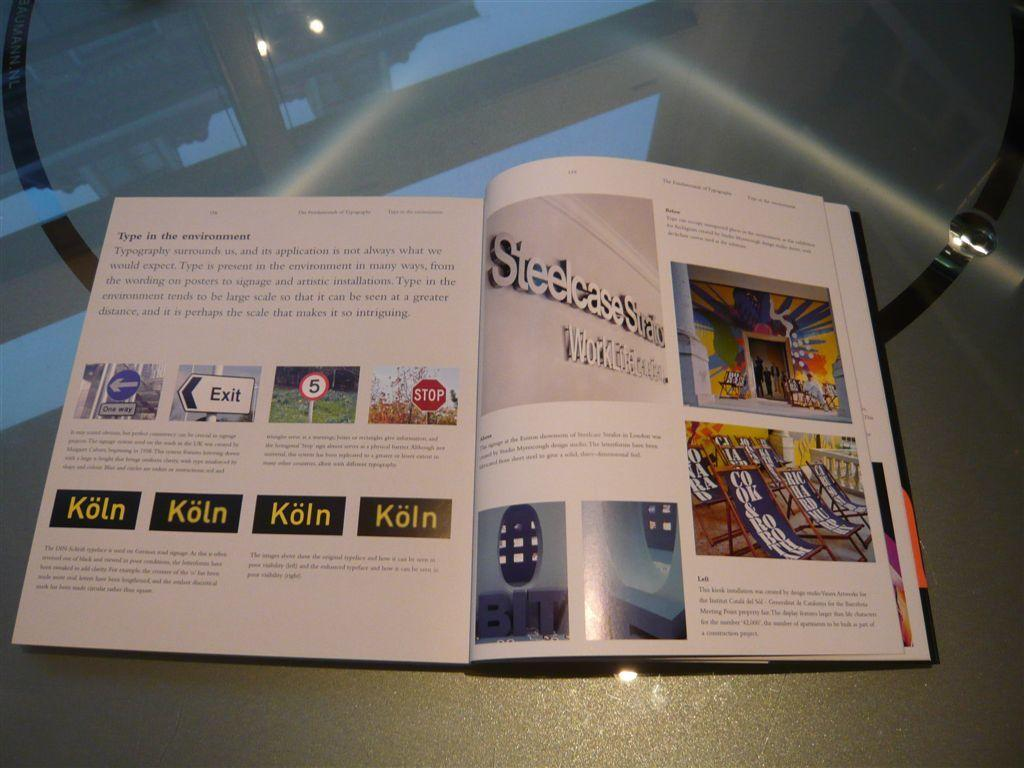<image>
Present a compact description of the photo's key features. An open book which deals with the subject of typography. 